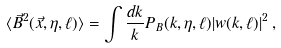Convert formula to latex. <formula><loc_0><loc_0><loc_500><loc_500>\langle \vec { B } ^ { 2 } ( \vec { x } , \eta , \ell ) \rangle = \int \frac { d k } { k } { P } _ { B } ( k , \eta , \ell ) | w ( k , \ell ) | ^ { 2 } \, ,</formula> 